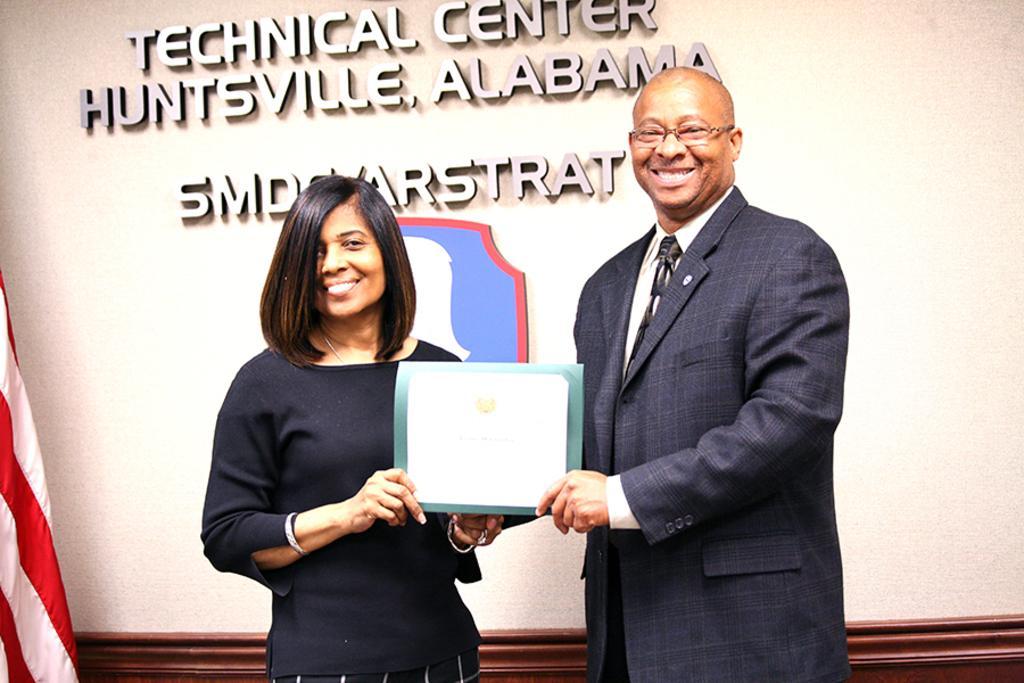Can you describe this image briefly? In the center of the image there are two persons holding a paper. In the background of the image there is wall and there is some text on it. To the left side of the image there is flag. 